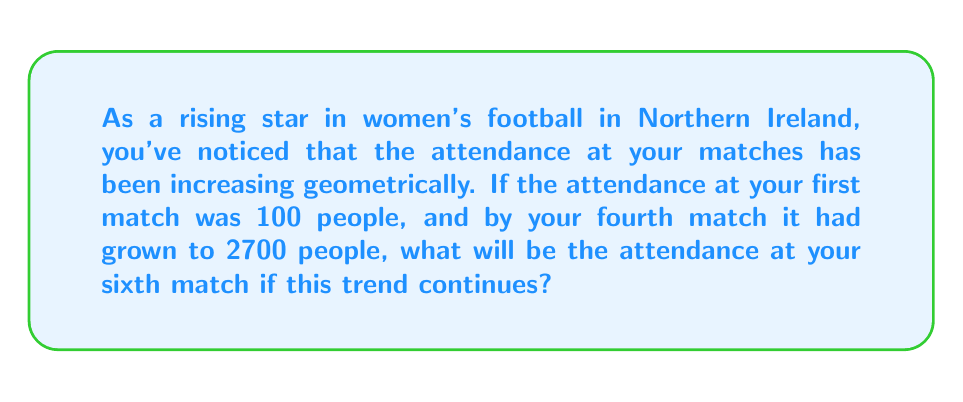What is the answer to this math problem? Let's approach this step-by-step:

1) In a geometric sequence, each term is a constant multiple of the previous term. Let's call this constant $r$.

2) We know the first term $a_1 = 100$ and the fourth term $a_4 = 2700$.

3) In a geometric sequence, we can express the fourth term as:
   $a_4 = a_1 \cdot r^3$

4) Substituting our known values:
   $2700 = 100 \cdot r^3$

5) Solving for $r$:
   $$\begin{align}
   27 &= r^3 \\
   r &= \sqrt[3]{27} = 3
   \end{align}$$

6) So, the common ratio is 3. Each term is 3 times the previous term.

7) Now, to find the sixth term, we can use the formula:
   $a_n = a_1 \cdot r^{n-1}$

8) For the sixth term:
   $$\begin{align}
   a_6 &= 100 \cdot 3^{6-1} \\
   &= 100 \cdot 3^5 \\
   &= 100 \cdot 243 \\
   &= 24,300
   \end{align}$$

Therefore, the attendance at the sixth match will be 24,300 people.
Answer: 24,300 people 